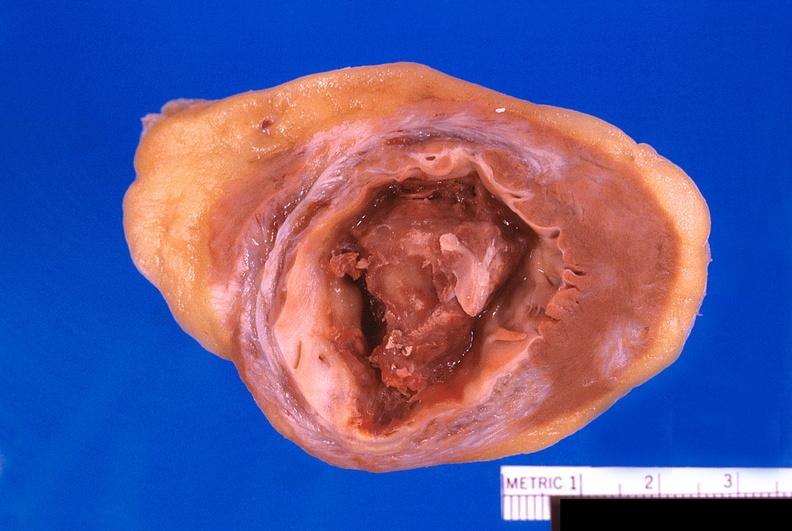s cardiovascular present?
Answer the question using a single word or phrase. Yes 